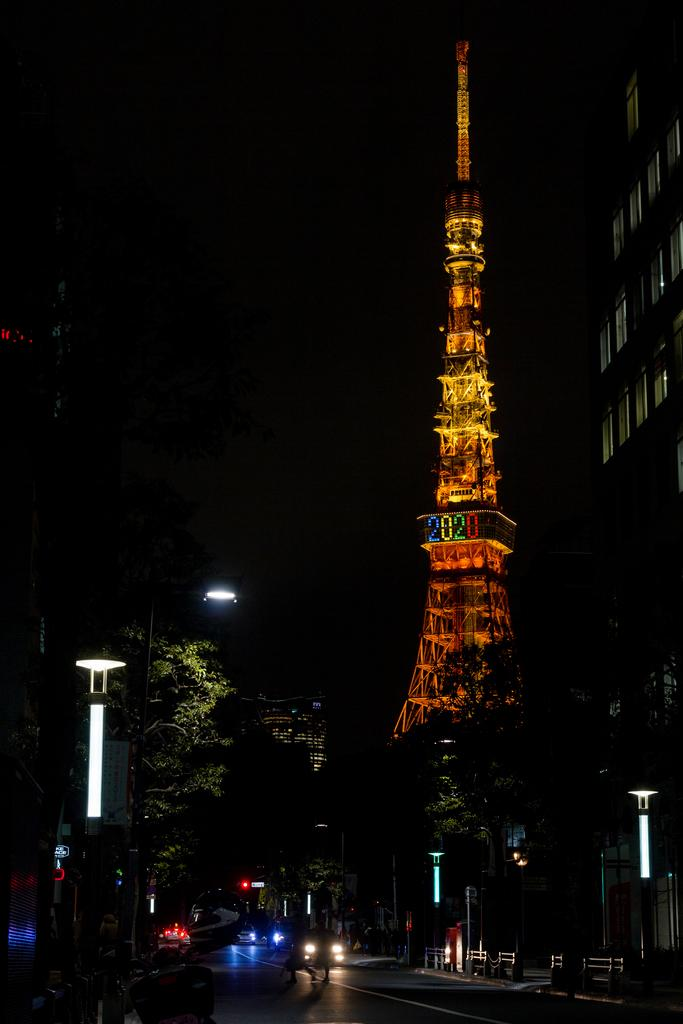What is the main structure in the image? There is a tower in the image. What type of natural elements can be seen in the image? There are trees in the image. What type of man-made structures are present in the image? There are buildings in the image. How would you describe the lighting in the image? The sky is dark in the image. What type of transportation is visible in the image? There are vehicles visible on the road in the image. How many slaves are visible in the image? There are no slaves present in the image. What type of drain is visible in the image? There is no drain present in the image. 